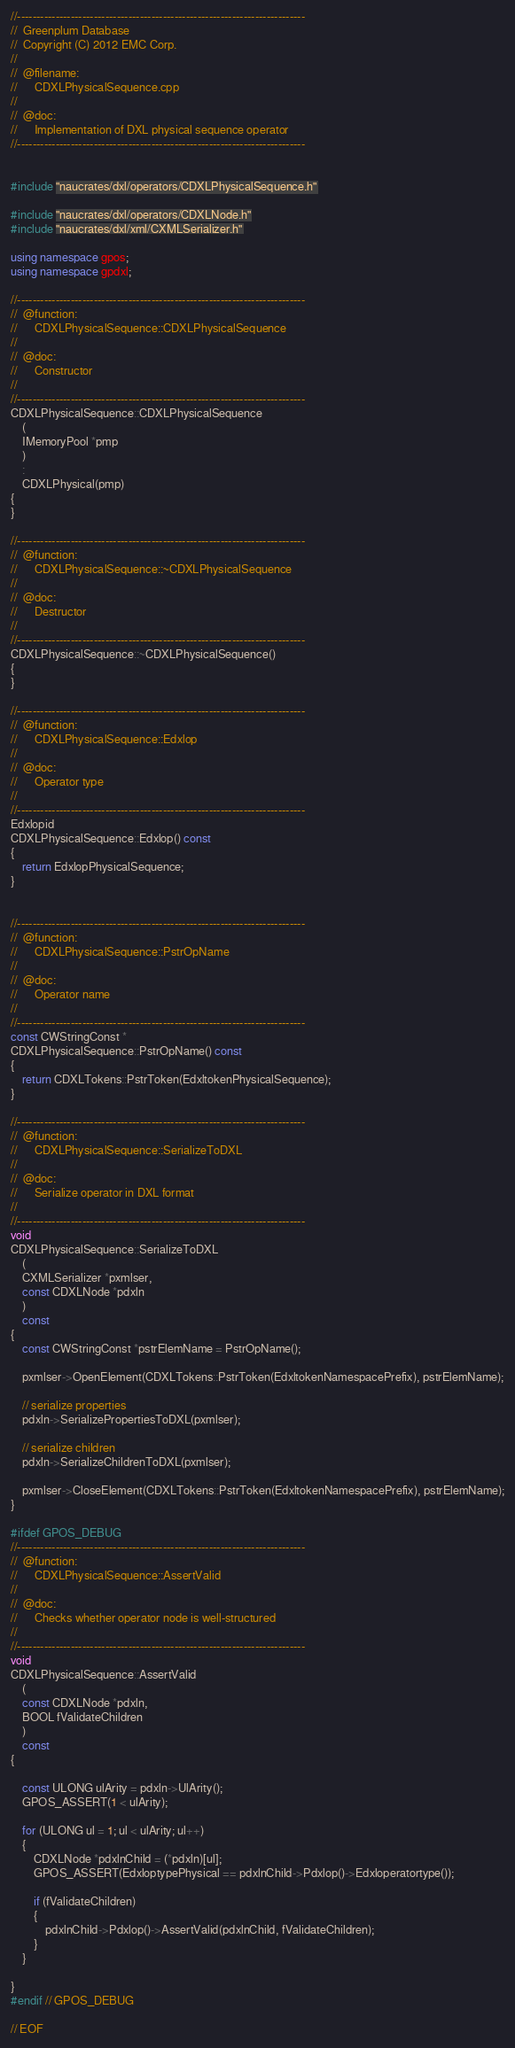Convert code to text. <code><loc_0><loc_0><loc_500><loc_500><_C++_>//---------------------------------------------------------------------------
//	Greenplum Database
//	Copyright (C) 2012 EMC Corp.
//
//	@filename:
//		CDXLPhysicalSequence.cpp
//
//	@doc:
//		Implementation of DXL physical sequence operator
//---------------------------------------------------------------------------


#include "naucrates/dxl/operators/CDXLPhysicalSequence.h"

#include "naucrates/dxl/operators/CDXLNode.h"
#include "naucrates/dxl/xml/CXMLSerializer.h"

using namespace gpos;
using namespace gpdxl;

//---------------------------------------------------------------------------
//	@function:
//		CDXLPhysicalSequence::CDXLPhysicalSequence
//
//	@doc:
//		Constructor
//
//---------------------------------------------------------------------------
CDXLPhysicalSequence::CDXLPhysicalSequence
	(
	IMemoryPool *pmp
	)
	:
	CDXLPhysical(pmp)
{
}

//---------------------------------------------------------------------------
//	@function:
//		CDXLPhysicalSequence::~CDXLPhysicalSequence
//
//	@doc:
//		Destructor
//
//---------------------------------------------------------------------------
CDXLPhysicalSequence::~CDXLPhysicalSequence()
{
}

//---------------------------------------------------------------------------
//	@function:
//		CDXLPhysicalSequence::Edxlop
//
//	@doc:
//		Operator type
//
//---------------------------------------------------------------------------
Edxlopid
CDXLPhysicalSequence::Edxlop() const
{
	return EdxlopPhysicalSequence;
}


//---------------------------------------------------------------------------
//	@function:
//		CDXLPhysicalSequence::PstrOpName
//
//	@doc:
//		Operator name
//
//---------------------------------------------------------------------------
const CWStringConst *
CDXLPhysicalSequence::PstrOpName() const
{
	return CDXLTokens::PstrToken(EdxltokenPhysicalSequence);
}

//---------------------------------------------------------------------------
//	@function:
//		CDXLPhysicalSequence::SerializeToDXL
//
//	@doc:
//		Serialize operator in DXL format
//
//---------------------------------------------------------------------------
void
CDXLPhysicalSequence::SerializeToDXL
	(
	CXMLSerializer *pxmlser,
	const CDXLNode *pdxln
	)
	const
{
	const CWStringConst *pstrElemName = PstrOpName();

	pxmlser->OpenElement(CDXLTokens::PstrToken(EdxltokenNamespacePrefix), pstrElemName);
		
	// serialize properties
	pdxln->SerializePropertiesToDXL(pxmlser);

	// serialize children
	pdxln->SerializeChildrenToDXL(pxmlser);

	pxmlser->CloseElement(CDXLTokens::PstrToken(EdxltokenNamespacePrefix), pstrElemName);
}

#ifdef GPOS_DEBUG
//---------------------------------------------------------------------------
//	@function:
//		CDXLPhysicalSequence::AssertValid
//
//	@doc:
//		Checks whether operator node is well-structured
//
//---------------------------------------------------------------------------
void
CDXLPhysicalSequence::AssertValid
	(
	const CDXLNode *pdxln,
	BOOL fValidateChildren
	) 
	const
{

	const ULONG ulArity = pdxln->UlArity();  
	GPOS_ASSERT(1 < ulArity);

	for (ULONG ul = 1; ul < ulArity; ul++)
	{
		CDXLNode *pdxlnChild = (*pdxln)[ul];
		GPOS_ASSERT(EdxloptypePhysical == pdxlnChild->Pdxlop()->Edxloperatortype());

		if (fValidateChildren)
		{
			pdxlnChild->Pdxlop()->AssertValid(pdxlnChild, fValidateChildren);
		}
	}

}
#endif // GPOS_DEBUG

// EOF
</code> 